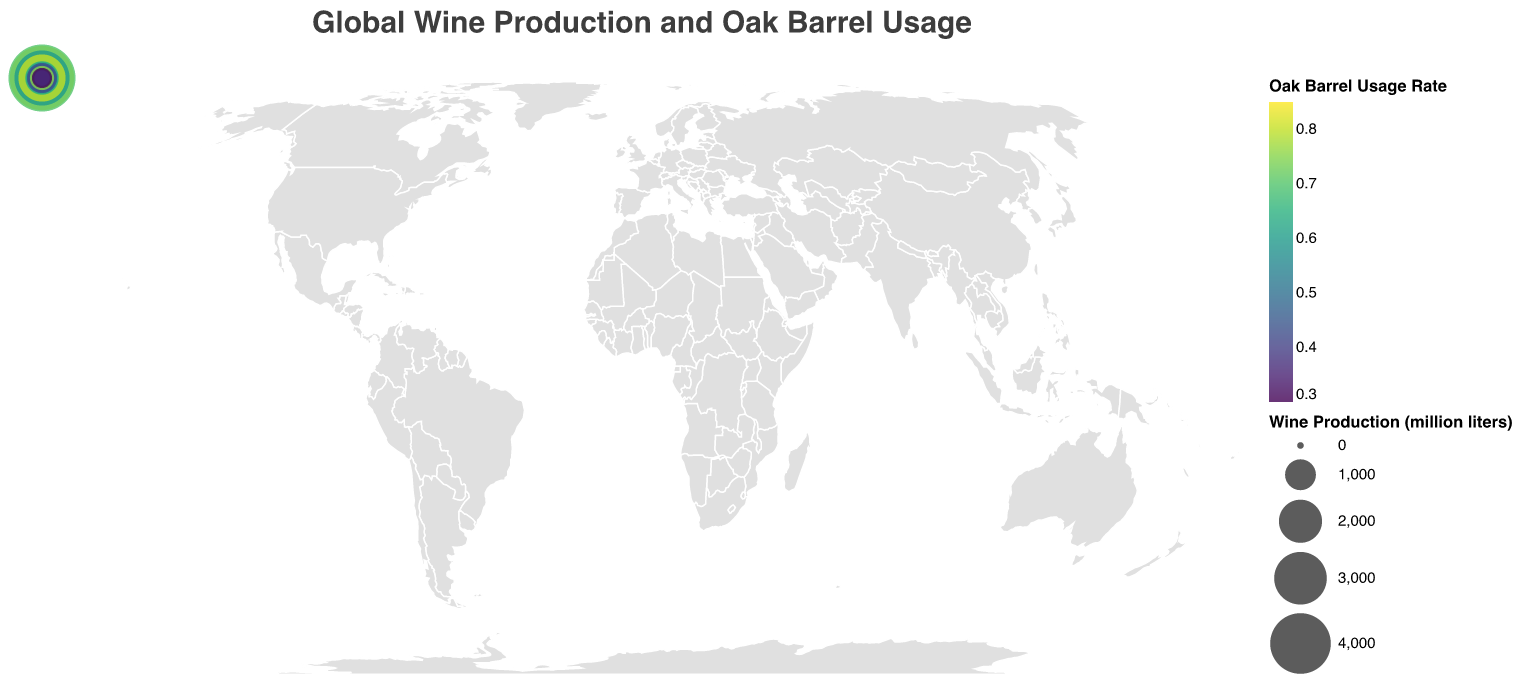What is the title of the figure? The title is typically positioned at the top of the figure and it succinctly describes what the figure is about. In this case, it states "Global Wine Production and Oak Barrel Usage."
Answer: Global Wine Production and Oak Barrel Usage How many countries are represented in the figure? Counting each unique country listed provides the total number of countries being analyzed. The list includes: France, Italy, Spain, United States, Argentina, Australia, Chile, Germany, South Africa, Portugal, New Zealand, Austria, Romania, Greece, and Hungary. Thus, there are fifteen countries.
Answer: 15 Which country has the highest wine production volume? The figure uses circle sizes to represent wine production volumes. By identifying the largest circle, we can determine that Italy, with 4900 million liters, has the highest production volume.
Answer: Italy What is the oak barrel usage rate for Portugal? By locating Portugal on the plot and checking the color coding or tooltip for oak barrel usage rates, we see that it is 75%.
Answer: 75% Which country has the lowest oak barrel usage rate and what is the value? The color coding for lower oak barrel usage rates tends to be a specific shade. By identifying Austria and Romania, we notice that they both share the lowest usage rate of 35%.
Answer: Austria and Romania, 35% Which countries have an oak barrel usage rate above 80%? By analyzing the color gradient on the plot, we can identify that France and the United States have oak barrel usage rates above 80%.
Answer: France and United States What is the total wine production volume for countries with at least 60% oak barrel usage rate? We sum the wine production volumes for France (4500), Italy (4900), Spain (3300), United States (2400), Portugal (600), and New Zealand (300), giving us a total of 16000 million liters.
Answer: 16000 million liters Compare the wine production volumes and oak barrel usage rates of Argentina and Chile. Argentina has a wine production volume of 1100 million liters and an oak barrel usage rate of 55%. Chile has a wine production volume of 950 million liters and a usage rate of 50%. Argentina produces more wine with a higher oak barrel usage rate.
Answer: Argentina produces more wine with higher oak barrel usage Which country uses oak barrels the least, and what percentage of their wine production is aged in oak barrels? Identifying the lowest oak barrel usage rate and checking the color and tooltip for that country reveals that Romania and Austria use oak barrels the least, both at 35%.
Answer: Romania and Austria, 35% What are the wine production volumes and oak barrel usage rates for the countries with the smallest and largest production volumes? The smallest production volume is in Greece with 200 million liters and a usage rate of 40%. The largest production volume is in Italy with 4900 million liters and a usage rate of 70%.
Answer: Greece: 200 million liters, 40%; Italy: 4900 million liters, 70% 